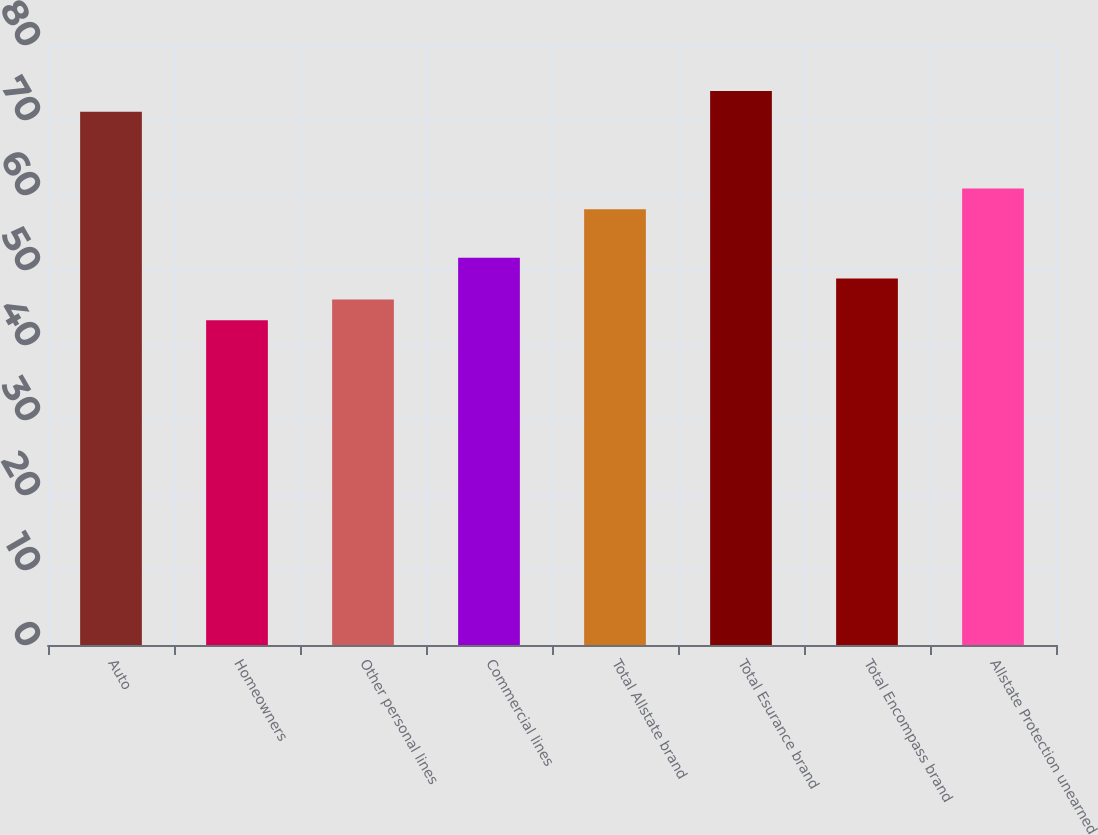Convert chart. <chart><loc_0><loc_0><loc_500><loc_500><bar_chart><fcel>Auto<fcel>Homeowners<fcel>Other personal lines<fcel>Commercial lines<fcel>Total Allstate brand<fcel>Total Esurance brand<fcel>Total Encompass brand<fcel>Allstate Protection unearned<nl><fcel>71.1<fcel>43.3<fcel>46.08<fcel>51.64<fcel>58.1<fcel>73.88<fcel>48.86<fcel>60.88<nl></chart> 